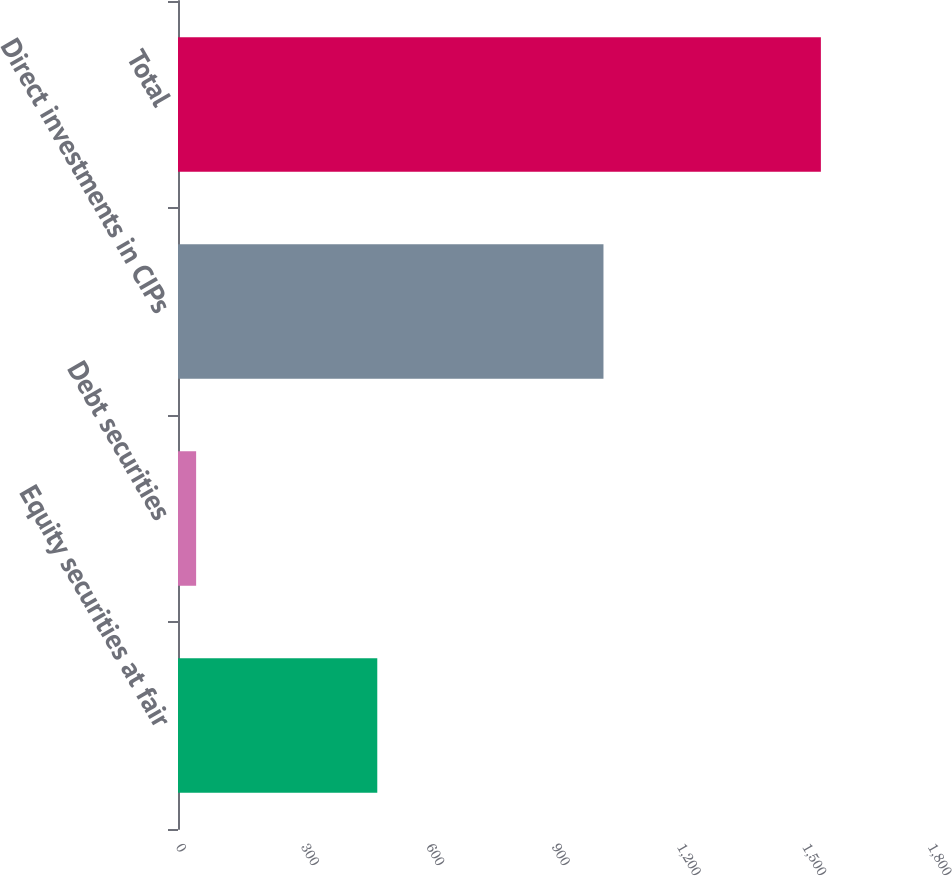Convert chart to OTSL. <chart><loc_0><loc_0><loc_500><loc_500><bar_chart><fcel>Equity securities at fair<fcel>Debt securities<fcel>Direct investments in CIPs<fcel>Total<nl><fcel>477<fcel>43.4<fcel>1018.4<fcel>1538.8<nl></chart> 